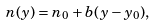Convert formula to latex. <formula><loc_0><loc_0><loc_500><loc_500>n ( y ) = n _ { 0 } + b ( y - y _ { 0 } ) ,</formula> 